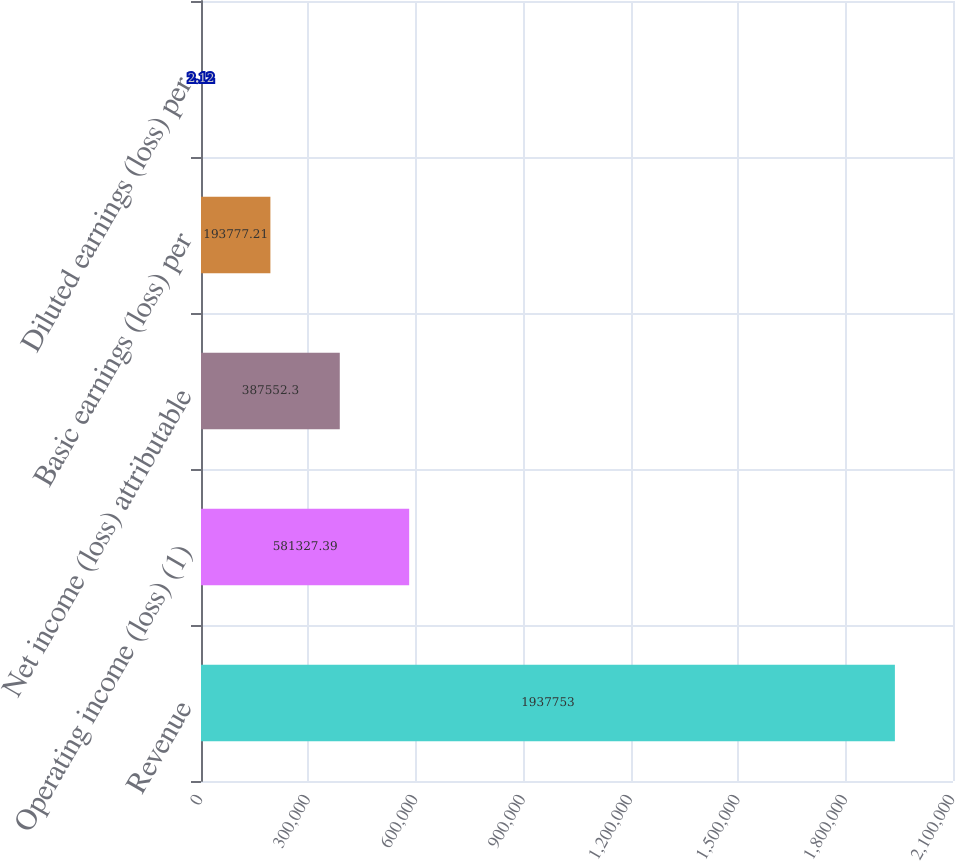<chart> <loc_0><loc_0><loc_500><loc_500><bar_chart><fcel>Revenue<fcel>Operating income (loss) (1)<fcel>Net income (loss) attributable<fcel>Basic earnings (loss) per<fcel>Diluted earnings (loss) per<nl><fcel>1.93775e+06<fcel>581327<fcel>387552<fcel>193777<fcel>2.12<nl></chart> 